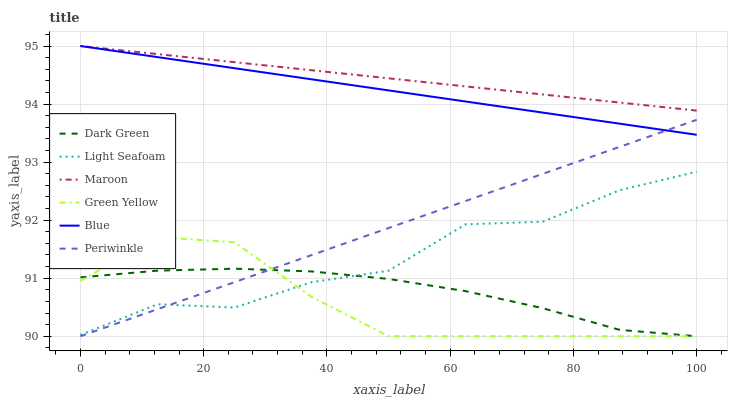Does Light Seafoam have the minimum area under the curve?
Answer yes or no. No. Does Light Seafoam have the maximum area under the curve?
Answer yes or no. No. Is Light Seafoam the smoothest?
Answer yes or no. No. Is Maroon the roughest?
Answer yes or no. No. Does Light Seafoam have the lowest value?
Answer yes or no. No. Does Light Seafoam have the highest value?
Answer yes or no. No. Is Dark Green less than Maroon?
Answer yes or no. Yes. Is Maroon greater than Light Seafoam?
Answer yes or no. Yes. Does Dark Green intersect Maroon?
Answer yes or no. No. 